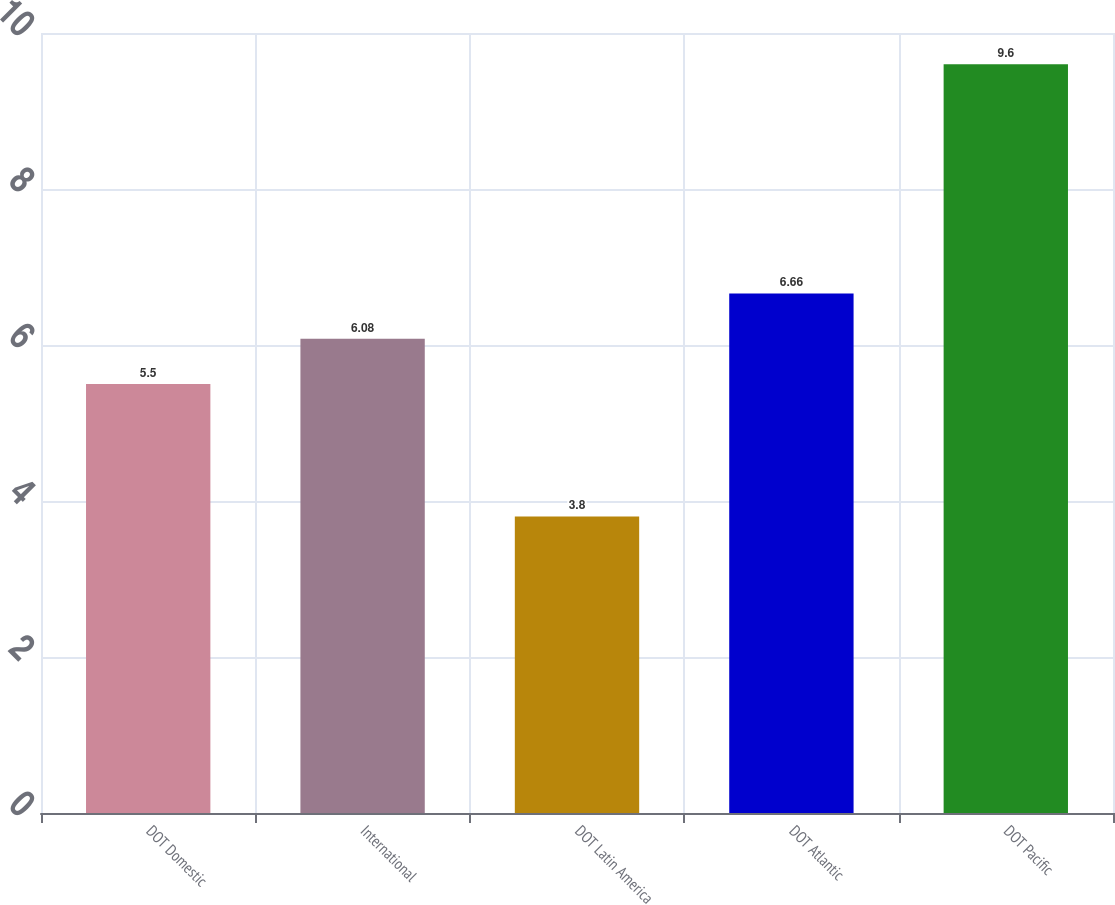Convert chart to OTSL. <chart><loc_0><loc_0><loc_500><loc_500><bar_chart><fcel>DOT Domestic<fcel>International<fcel>DOT Latin America<fcel>DOT Atlantic<fcel>DOT Pacific<nl><fcel>5.5<fcel>6.08<fcel>3.8<fcel>6.66<fcel>9.6<nl></chart> 